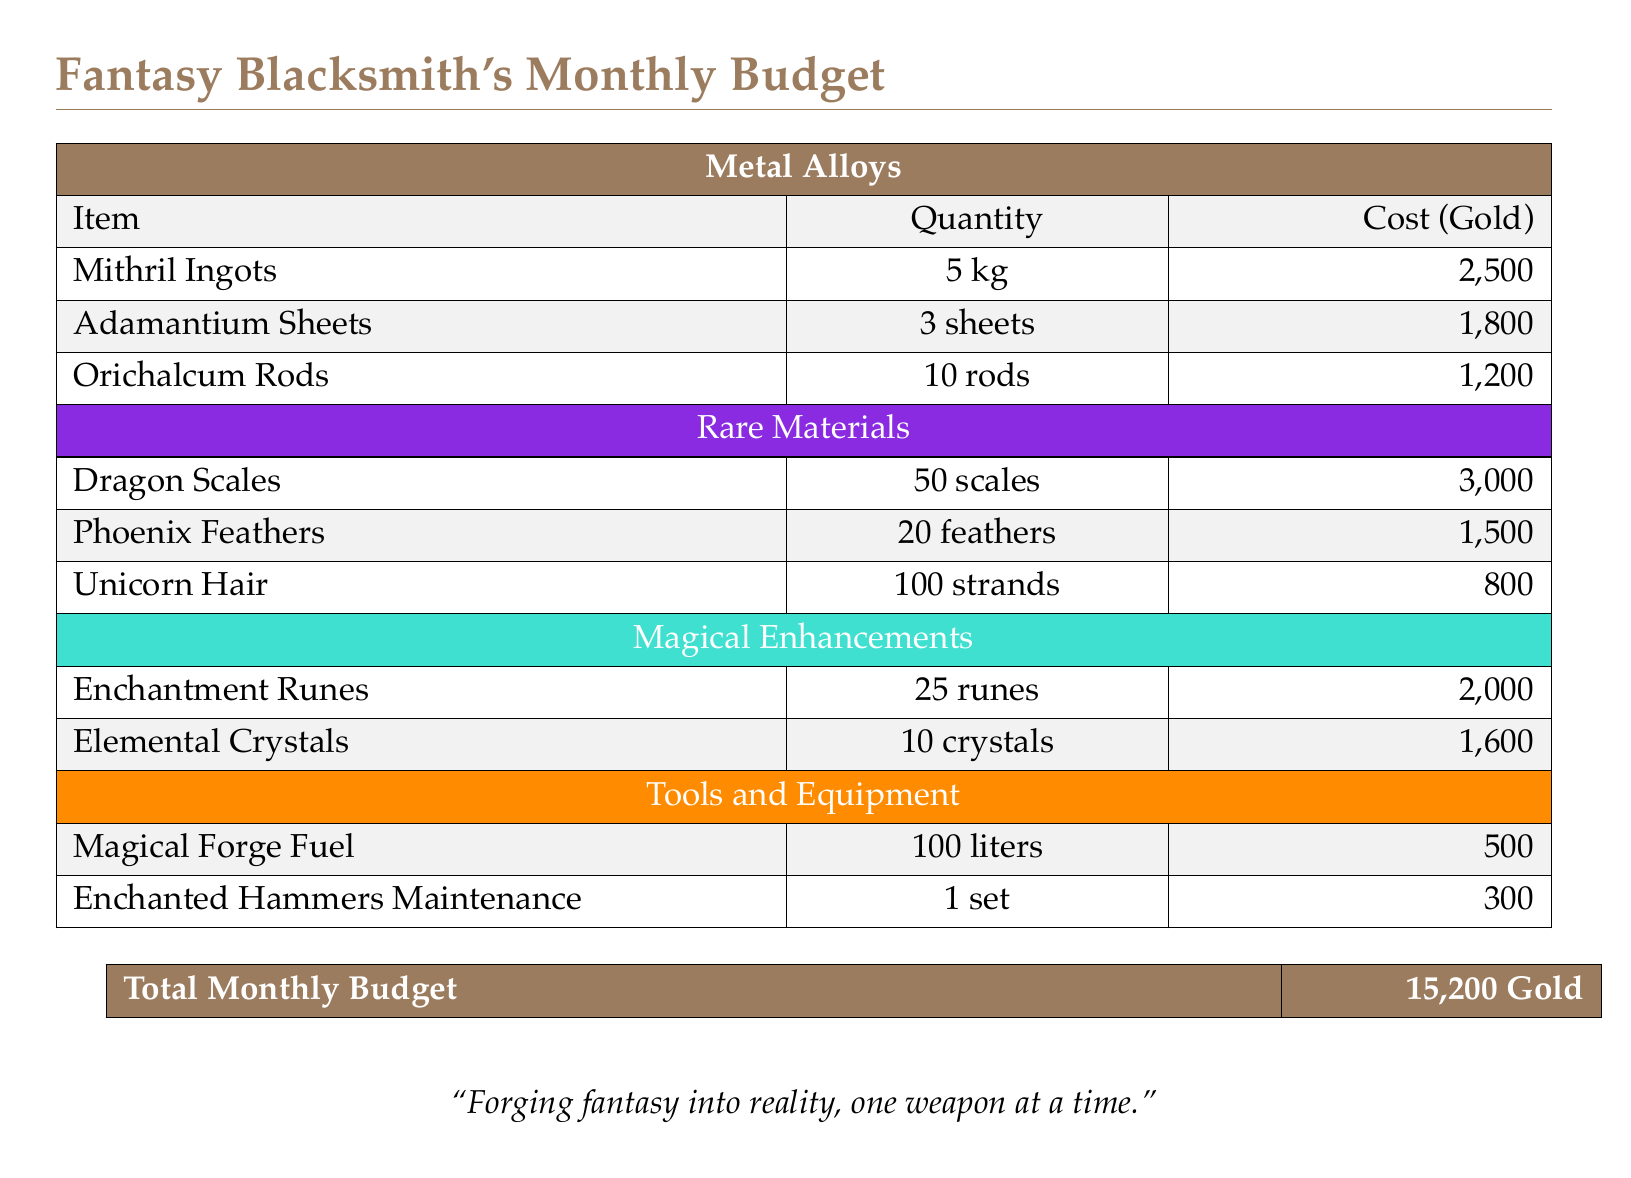What is the total monthly budget? The total monthly budget is shown at the end of the document, summarizing all expenses listed above.
Answer: 15,200 Gold How many kilograms of Mithril Ingots are there? The document specifies the quantity of Mithril Ingots, which is directly noted in the items list.
Answer: 5 kg What is the cost of Dragon Scales? The document provides a specific cost for Dragon Scales in the Rare Materials section.
Answer: 3,000 How many Phoenix Feathers are required? The document lists the required quantity for Phoenix Feathers under the Rare Materials category.
Answer: 20 feathers What is the total cost of Magical Enhancements? To find the total cost, we must add the costs of Enchantment Runes and Elemental Crystals listed in the document.
Answer: 3,600 How many strands of Unicorn Hair are needed? The quantity of Unicorn Hair necessary is specified in the Rare Materials section of the document.
Answer: 100 strands What type of fuel is used for the forge? The document lists a specific type of fuel required for the forging process.
Answer: Magical Forge Fuel What maintenance cost is listed for Enchanted Hammers? The specific cost for maintaining Enchanted Hammers is directly mentioned in the Tools and Equipment section.
Answer: 300 